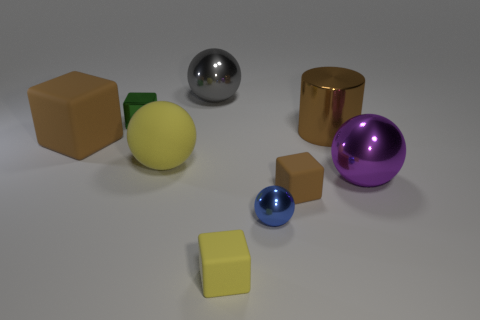Add 1 gray objects. How many objects exist? 10 Subtract all cylinders. How many objects are left? 8 Subtract 1 blue spheres. How many objects are left? 8 Subtract all small yellow shiny things. Subtract all large blocks. How many objects are left? 8 Add 2 tiny green shiny objects. How many tiny green shiny objects are left? 3 Add 9 large yellow metallic cylinders. How many large yellow metallic cylinders exist? 9 